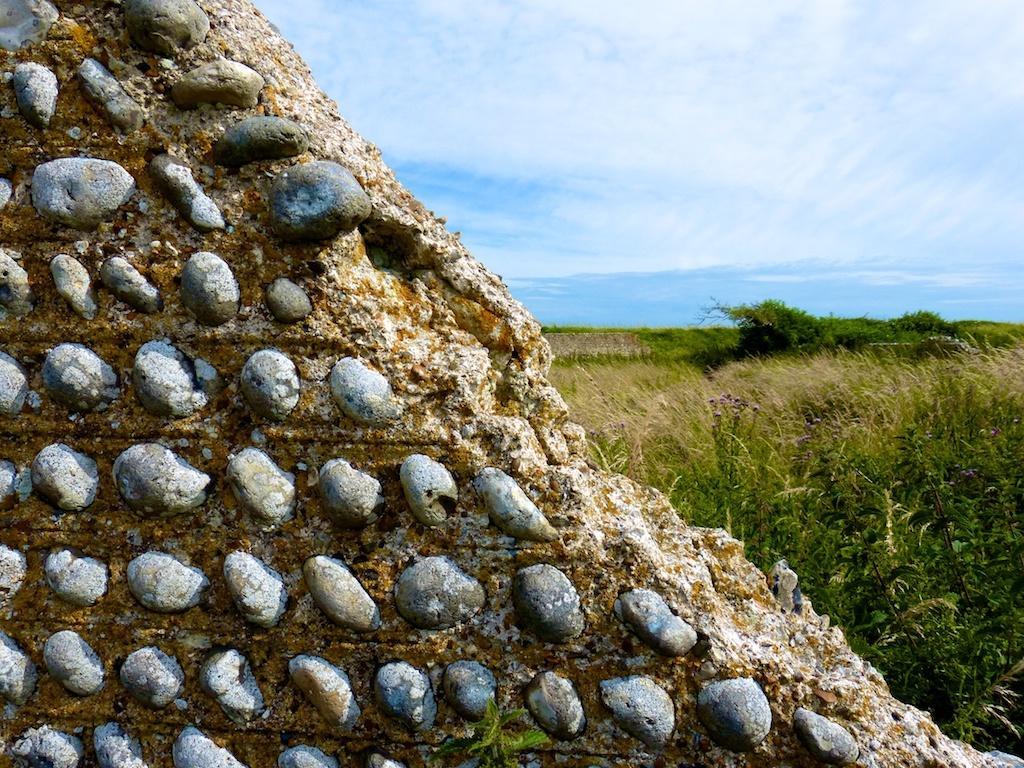Please provide a concise description of this image. In this image we can see some stones to a wall. On the backside we can see some plants, grass, tree and the sky which looks cloudy. 